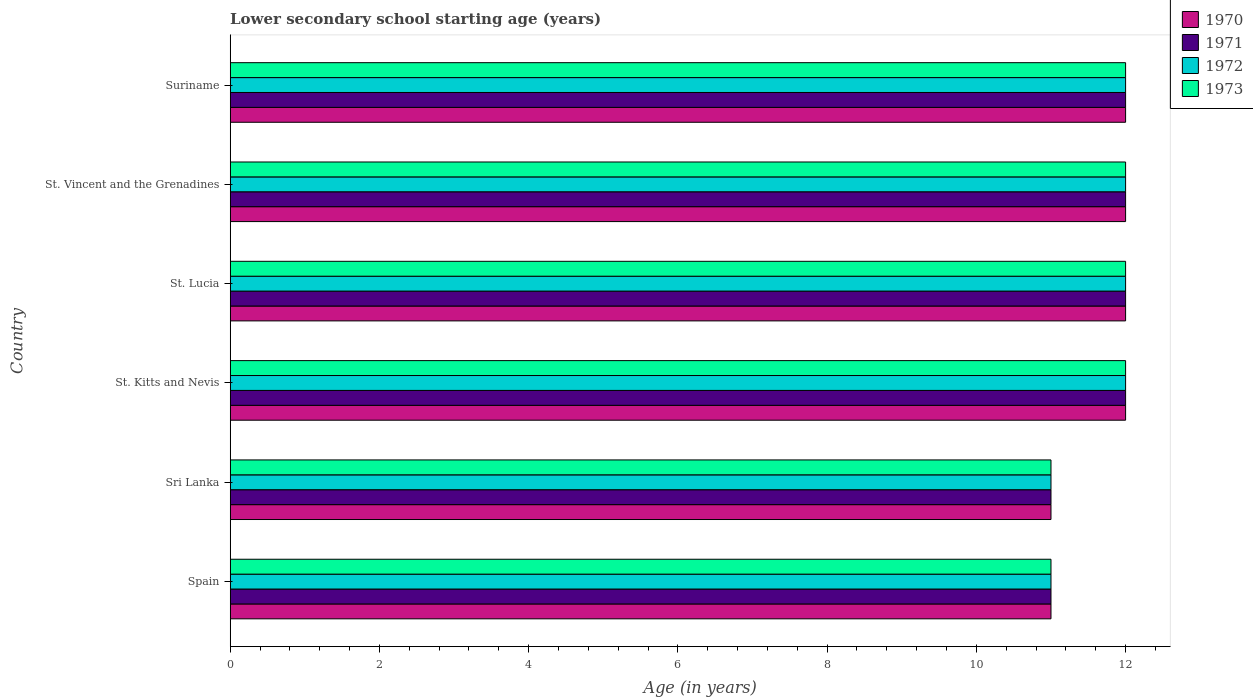How many groups of bars are there?
Offer a terse response. 6. Are the number of bars per tick equal to the number of legend labels?
Your response must be concise. Yes. How many bars are there on the 1st tick from the bottom?
Make the answer very short. 4. What is the label of the 2nd group of bars from the top?
Your response must be concise. St. Vincent and the Grenadines. In how many cases, is the number of bars for a given country not equal to the number of legend labels?
Provide a short and direct response. 0. What is the lower secondary school starting age of children in 1970 in St. Kitts and Nevis?
Offer a terse response. 12. Across all countries, what is the maximum lower secondary school starting age of children in 1973?
Provide a succinct answer. 12. Across all countries, what is the minimum lower secondary school starting age of children in 1973?
Offer a terse response. 11. In which country was the lower secondary school starting age of children in 1970 maximum?
Your response must be concise. St. Kitts and Nevis. What is the average lower secondary school starting age of children in 1972 per country?
Keep it short and to the point. 11.67. In how many countries, is the lower secondary school starting age of children in 1971 greater than 0.8 years?
Keep it short and to the point. 6. What is the ratio of the lower secondary school starting age of children in 1970 in Spain to that in Suriname?
Offer a terse response. 0.92. Is the difference between the lower secondary school starting age of children in 1972 in Sri Lanka and St. Lucia greater than the difference between the lower secondary school starting age of children in 1973 in Sri Lanka and St. Lucia?
Ensure brevity in your answer.  No. In how many countries, is the lower secondary school starting age of children in 1971 greater than the average lower secondary school starting age of children in 1971 taken over all countries?
Offer a very short reply. 4. Is the sum of the lower secondary school starting age of children in 1970 in St. Kitts and Nevis and St. Vincent and the Grenadines greater than the maximum lower secondary school starting age of children in 1972 across all countries?
Your response must be concise. Yes. What does the 2nd bar from the top in St. Vincent and the Grenadines represents?
Offer a very short reply. 1972. What does the 1st bar from the bottom in St. Kitts and Nevis represents?
Make the answer very short. 1970. How many bars are there?
Keep it short and to the point. 24. What is the difference between two consecutive major ticks on the X-axis?
Offer a very short reply. 2. Are the values on the major ticks of X-axis written in scientific E-notation?
Provide a succinct answer. No. Does the graph contain any zero values?
Provide a short and direct response. No. Where does the legend appear in the graph?
Provide a short and direct response. Top right. What is the title of the graph?
Provide a succinct answer. Lower secondary school starting age (years). What is the label or title of the X-axis?
Your response must be concise. Age (in years). What is the Age (in years) of 1971 in Spain?
Your answer should be compact. 11. What is the Age (in years) of 1973 in Spain?
Your response must be concise. 11. What is the Age (in years) of 1970 in Sri Lanka?
Your answer should be very brief. 11. What is the Age (in years) of 1970 in St. Lucia?
Provide a short and direct response. 12. What is the Age (in years) of 1972 in St. Lucia?
Your answer should be compact. 12. What is the Age (in years) in 1971 in St. Vincent and the Grenadines?
Provide a short and direct response. 12. What is the Age (in years) in 1973 in St. Vincent and the Grenadines?
Make the answer very short. 12. What is the Age (in years) in 1972 in Suriname?
Your answer should be compact. 12. Across all countries, what is the maximum Age (in years) of 1971?
Your answer should be compact. 12. Across all countries, what is the maximum Age (in years) in 1972?
Give a very brief answer. 12. Across all countries, what is the minimum Age (in years) in 1971?
Your answer should be compact. 11. What is the total Age (in years) in 1970 in the graph?
Your answer should be compact. 70. What is the total Age (in years) in 1971 in the graph?
Your answer should be very brief. 70. What is the total Age (in years) in 1972 in the graph?
Give a very brief answer. 70. What is the difference between the Age (in years) of 1970 in Spain and that in Sri Lanka?
Ensure brevity in your answer.  0. What is the difference between the Age (in years) of 1972 in Spain and that in Sri Lanka?
Your response must be concise. 0. What is the difference between the Age (in years) of 1970 in Spain and that in St. Kitts and Nevis?
Your answer should be very brief. -1. What is the difference between the Age (in years) of 1973 in Spain and that in St. Kitts and Nevis?
Ensure brevity in your answer.  -1. What is the difference between the Age (in years) in 1970 in Spain and that in St. Lucia?
Ensure brevity in your answer.  -1. What is the difference between the Age (in years) of 1970 in Spain and that in St. Vincent and the Grenadines?
Keep it short and to the point. -1. What is the difference between the Age (in years) in 1971 in Spain and that in St. Vincent and the Grenadines?
Offer a very short reply. -1. What is the difference between the Age (in years) of 1973 in Spain and that in St. Vincent and the Grenadines?
Your answer should be compact. -1. What is the difference between the Age (in years) in 1970 in Spain and that in Suriname?
Keep it short and to the point. -1. What is the difference between the Age (in years) in 1971 in Spain and that in Suriname?
Offer a very short reply. -1. What is the difference between the Age (in years) in 1972 in Spain and that in Suriname?
Your answer should be compact. -1. What is the difference between the Age (in years) of 1972 in Sri Lanka and that in St. Kitts and Nevis?
Provide a short and direct response. -1. What is the difference between the Age (in years) in 1970 in Sri Lanka and that in St. Lucia?
Your answer should be very brief. -1. What is the difference between the Age (in years) of 1971 in Sri Lanka and that in St. Lucia?
Keep it short and to the point. -1. What is the difference between the Age (in years) of 1973 in Sri Lanka and that in St. Lucia?
Offer a terse response. -1. What is the difference between the Age (in years) in 1970 in Sri Lanka and that in St. Vincent and the Grenadines?
Ensure brevity in your answer.  -1. What is the difference between the Age (in years) in 1971 in Sri Lanka and that in St. Vincent and the Grenadines?
Your answer should be very brief. -1. What is the difference between the Age (in years) of 1972 in Sri Lanka and that in St. Vincent and the Grenadines?
Make the answer very short. -1. What is the difference between the Age (in years) of 1973 in Sri Lanka and that in St. Vincent and the Grenadines?
Your answer should be very brief. -1. What is the difference between the Age (in years) in 1971 in Sri Lanka and that in Suriname?
Offer a terse response. -1. What is the difference between the Age (in years) in 1973 in Sri Lanka and that in Suriname?
Your response must be concise. -1. What is the difference between the Age (in years) of 1971 in St. Kitts and Nevis and that in St. Lucia?
Give a very brief answer. 0. What is the difference between the Age (in years) of 1972 in St. Kitts and Nevis and that in St. Lucia?
Offer a very short reply. 0. What is the difference between the Age (in years) of 1970 in St. Kitts and Nevis and that in St. Vincent and the Grenadines?
Provide a short and direct response. 0. What is the difference between the Age (in years) in 1971 in St. Kitts and Nevis and that in Suriname?
Your response must be concise. 0. What is the difference between the Age (in years) of 1972 in St. Lucia and that in St. Vincent and the Grenadines?
Give a very brief answer. 0. What is the difference between the Age (in years) of 1973 in St. Lucia and that in St. Vincent and the Grenadines?
Keep it short and to the point. 0. What is the difference between the Age (in years) of 1971 in St. Lucia and that in Suriname?
Make the answer very short. 0. What is the difference between the Age (in years) of 1971 in St. Vincent and the Grenadines and that in Suriname?
Offer a terse response. 0. What is the difference between the Age (in years) in 1973 in St. Vincent and the Grenadines and that in Suriname?
Give a very brief answer. 0. What is the difference between the Age (in years) in 1970 in Spain and the Age (in years) in 1971 in Sri Lanka?
Offer a very short reply. 0. What is the difference between the Age (in years) in 1970 in Spain and the Age (in years) in 1972 in Sri Lanka?
Give a very brief answer. 0. What is the difference between the Age (in years) of 1970 in Spain and the Age (in years) of 1973 in Sri Lanka?
Your answer should be compact. 0. What is the difference between the Age (in years) of 1971 in Spain and the Age (in years) of 1973 in Sri Lanka?
Your answer should be very brief. 0. What is the difference between the Age (in years) of 1972 in Spain and the Age (in years) of 1973 in Sri Lanka?
Give a very brief answer. 0. What is the difference between the Age (in years) in 1970 in Spain and the Age (in years) in 1972 in St. Kitts and Nevis?
Keep it short and to the point. -1. What is the difference between the Age (in years) of 1971 in Spain and the Age (in years) of 1973 in St. Kitts and Nevis?
Ensure brevity in your answer.  -1. What is the difference between the Age (in years) of 1972 in Spain and the Age (in years) of 1973 in St. Kitts and Nevis?
Ensure brevity in your answer.  -1. What is the difference between the Age (in years) of 1970 in Spain and the Age (in years) of 1973 in St. Lucia?
Give a very brief answer. -1. What is the difference between the Age (in years) in 1971 in Spain and the Age (in years) in 1973 in St. Lucia?
Make the answer very short. -1. What is the difference between the Age (in years) of 1972 in Spain and the Age (in years) of 1973 in St. Lucia?
Your response must be concise. -1. What is the difference between the Age (in years) of 1970 in Spain and the Age (in years) of 1971 in St. Vincent and the Grenadines?
Your response must be concise. -1. What is the difference between the Age (in years) in 1970 in Spain and the Age (in years) in 1973 in St. Vincent and the Grenadines?
Make the answer very short. -1. What is the difference between the Age (in years) in 1971 in Spain and the Age (in years) in 1972 in St. Vincent and the Grenadines?
Provide a succinct answer. -1. What is the difference between the Age (in years) of 1970 in Spain and the Age (in years) of 1971 in Suriname?
Give a very brief answer. -1. What is the difference between the Age (in years) of 1970 in Spain and the Age (in years) of 1973 in Suriname?
Your answer should be very brief. -1. What is the difference between the Age (in years) of 1971 in Spain and the Age (in years) of 1972 in Suriname?
Your answer should be compact. -1. What is the difference between the Age (in years) in 1971 in Sri Lanka and the Age (in years) in 1972 in St. Kitts and Nevis?
Your answer should be very brief. -1. What is the difference between the Age (in years) of 1971 in Sri Lanka and the Age (in years) of 1973 in St. Kitts and Nevis?
Provide a short and direct response. -1. What is the difference between the Age (in years) in 1970 in Sri Lanka and the Age (in years) in 1973 in St. Lucia?
Make the answer very short. -1. What is the difference between the Age (in years) in 1971 in Sri Lanka and the Age (in years) in 1972 in St. Lucia?
Your answer should be compact. -1. What is the difference between the Age (in years) in 1971 in Sri Lanka and the Age (in years) in 1973 in St. Lucia?
Ensure brevity in your answer.  -1. What is the difference between the Age (in years) of 1970 in Sri Lanka and the Age (in years) of 1971 in St. Vincent and the Grenadines?
Your answer should be compact. -1. What is the difference between the Age (in years) of 1970 in Sri Lanka and the Age (in years) of 1973 in St. Vincent and the Grenadines?
Keep it short and to the point. -1. What is the difference between the Age (in years) in 1971 in Sri Lanka and the Age (in years) in 1973 in St. Vincent and the Grenadines?
Keep it short and to the point. -1. What is the difference between the Age (in years) of 1970 in Sri Lanka and the Age (in years) of 1971 in Suriname?
Provide a succinct answer. -1. What is the difference between the Age (in years) in 1970 in Sri Lanka and the Age (in years) in 1973 in Suriname?
Offer a terse response. -1. What is the difference between the Age (in years) of 1971 in Sri Lanka and the Age (in years) of 1973 in Suriname?
Ensure brevity in your answer.  -1. What is the difference between the Age (in years) in 1972 in St. Kitts and Nevis and the Age (in years) in 1973 in St. Lucia?
Offer a very short reply. 0. What is the difference between the Age (in years) of 1970 in St. Kitts and Nevis and the Age (in years) of 1971 in St. Vincent and the Grenadines?
Offer a terse response. 0. What is the difference between the Age (in years) of 1972 in St. Kitts and Nevis and the Age (in years) of 1973 in St. Vincent and the Grenadines?
Your answer should be compact. 0. What is the difference between the Age (in years) in 1970 in St. Kitts and Nevis and the Age (in years) in 1971 in Suriname?
Offer a terse response. 0. What is the difference between the Age (in years) in 1970 in St. Kitts and Nevis and the Age (in years) in 1973 in Suriname?
Your response must be concise. 0. What is the difference between the Age (in years) of 1971 in St. Kitts and Nevis and the Age (in years) of 1972 in Suriname?
Give a very brief answer. 0. What is the difference between the Age (in years) in 1971 in St. Kitts and Nevis and the Age (in years) in 1973 in Suriname?
Keep it short and to the point. 0. What is the difference between the Age (in years) of 1970 in St. Lucia and the Age (in years) of 1971 in St. Vincent and the Grenadines?
Offer a very short reply. 0. What is the difference between the Age (in years) of 1970 in St. Lucia and the Age (in years) of 1972 in St. Vincent and the Grenadines?
Offer a terse response. 0. What is the difference between the Age (in years) in 1970 in St. Lucia and the Age (in years) in 1973 in St. Vincent and the Grenadines?
Make the answer very short. 0. What is the difference between the Age (in years) of 1971 in St. Lucia and the Age (in years) of 1972 in St. Vincent and the Grenadines?
Provide a short and direct response. 0. What is the difference between the Age (in years) of 1970 in St. Lucia and the Age (in years) of 1972 in Suriname?
Give a very brief answer. 0. What is the difference between the Age (in years) in 1970 in St. Lucia and the Age (in years) in 1973 in Suriname?
Your answer should be compact. 0. What is the difference between the Age (in years) in 1971 in St. Lucia and the Age (in years) in 1972 in Suriname?
Your answer should be very brief. 0. What is the difference between the Age (in years) of 1971 in St. Lucia and the Age (in years) of 1973 in Suriname?
Your response must be concise. 0. What is the difference between the Age (in years) in 1972 in St. Lucia and the Age (in years) in 1973 in Suriname?
Your response must be concise. 0. What is the difference between the Age (in years) of 1970 in St. Vincent and the Grenadines and the Age (in years) of 1973 in Suriname?
Your response must be concise. 0. What is the average Age (in years) in 1970 per country?
Your response must be concise. 11.67. What is the average Age (in years) in 1971 per country?
Your answer should be compact. 11.67. What is the average Age (in years) of 1972 per country?
Your response must be concise. 11.67. What is the average Age (in years) of 1973 per country?
Offer a terse response. 11.67. What is the difference between the Age (in years) of 1970 and Age (in years) of 1971 in Spain?
Your answer should be compact. 0. What is the difference between the Age (in years) in 1970 and Age (in years) in 1973 in Spain?
Your answer should be compact. 0. What is the difference between the Age (in years) of 1971 and Age (in years) of 1972 in Spain?
Your answer should be compact. 0. What is the difference between the Age (in years) in 1971 and Age (in years) in 1973 in Spain?
Your answer should be compact. 0. What is the difference between the Age (in years) in 1970 and Age (in years) in 1972 in Sri Lanka?
Keep it short and to the point. 0. What is the difference between the Age (in years) of 1970 and Age (in years) of 1973 in Sri Lanka?
Provide a short and direct response. 0. What is the difference between the Age (in years) in 1971 and Age (in years) in 1973 in Sri Lanka?
Give a very brief answer. 0. What is the difference between the Age (in years) in 1970 and Age (in years) in 1971 in St. Kitts and Nevis?
Provide a short and direct response. 0. What is the difference between the Age (in years) of 1970 and Age (in years) of 1972 in St. Kitts and Nevis?
Provide a short and direct response. 0. What is the difference between the Age (in years) of 1972 and Age (in years) of 1973 in St. Kitts and Nevis?
Make the answer very short. 0. What is the difference between the Age (in years) in 1970 and Age (in years) in 1973 in St. Lucia?
Your answer should be compact. 0. What is the difference between the Age (in years) in 1972 and Age (in years) in 1973 in St. Lucia?
Make the answer very short. 0. What is the difference between the Age (in years) of 1970 and Age (in years) of 1971 in St. Vincent and the Grenadines?
Give a very brief answer. 0. What is the difference between the Age (in years) of 1971 and Age (in years) of 1973 in St. Vincent and the Grenadines?
Give a very brief answer. 0. What is the difference between the Age (in years) of 1972 and Age (in years) of 1973 in St. Vincent and the Grenadines?
Provide a short and direct response. 0. What is the difference between the Age (in years) of 1970 and Age (in years) of 1971 in Suriname?
Your answer should be compact. 0. What is the difference between the Age (in years) of 1970 and Age (in years) of 1972 in Suriname?
Keep it short and to the point. 0. What is the difference between the Age (in years) in 1970 and Age (in years) in 1973 in Suriname?
Offer a terse response. 0. What is the difference between the Age (in years) of 1971 and Age (in years) of 1972 in Suriname?
Your answer should be very brief. 0. What is the ratio of the Age (in years) of 1972 in Spain to that in Sri Lanka?
Ensure brevity in your answer.  1. What is the ratio of the Age (in years) of 1973 in Spain to that in St. Kitts and Nevis?
Your response must be concise. 0.92. What is the ratio of the Age (in years) of 1971 in Spain to that in St. Lucia?
Provide a short and direct response. 0.92. What is the ratio of the Age (in years) in 1973 in Spain to that in St. Lucia?
Ensure brevity in your answer.  0.92. What is the ratio of the Age (in years) in 1971 in Spain to that in St. Vincent and the Grenadines?
Your answer should be very brief. 0.92. What is the ratio of the Age (in years) of 1972 in Spain to that in St. Vincent and the Grenadines?
Keep it short and to the point. 0.92. What is the ratio of the Age (in years) of 1973 in Spain to that in St. Vincent and the Grenadines?
Offer a very short reply. 0.92. What is the ratio of the Age (in years) of 1971 in Spain to that in Suriname?
Keep it short and to the point. 0.92. What is the ratio of the Age (in years) of 1973 in Spain to that in Suriname?
Give a very brief answer. 0.92. What is the ratio of the Age (in years) of 1972 in Sri Lanka to that in St. Kitts and Nevis?
Your response must be concise. 0.92. What is the ratio of the Age (in years) of 1973 in Sri Lanka to that in St. Kitts and Nevis?
Provide a succinct answer. 0.92. What is the ratio of the Age (in years) of 1973 in Sri Lanka to that in St. Lucia?
Provide a succinct answer. 0.92. What is the ratio of the Age (in years) of 1971 in Sri Lanka to that in St. Vincent and the Grenadines?
Your answer should be compact. 0.92. What is the ratio of the Age (in years) of 1970 in Sri Lanka to that in Suriname?
Offer a terse response. 0.92. What is the ratio of the Age (in years) of 1971 in Sri Lanka to that in Suriname?
Ensure brevity in your answer.  0.92. What is the ratio of the Age (in years) in 1972 in Sri Lanka to that in Suriname?
Keep it short and to the point. 0.92. What is the ratio of the Age (in years) of 1973 in Sri Lanka to that in Suriname?
Make the answer very short. 0.92. What is the ratio of the Age (in years) of 1972 in St. Kitts and Nevis to that in St. Lucia?
Your answer should be compact. 1. What is the ratio of the Age (in years) of 1973 in St. Kitts and Nevis to that in St. Lucia?
Give a very brief answer. 1. What is the ratio of the Age (in years) in 1970 in St. Kitts and Nevis to that in St. Vincent and the Grenadines?
Provide a succinct answer. 1. What is the ratio of the Age (in years) of 1973 in St. Kitts and Nevis to that in St. Vincent and the Grenadines?
Keep it short and to the point. 1. What is the ratio of the Age (in years) of 1971 in St. Kitts and Nevis to that in Suriname?
Ensure brevity in your answer.  1. What is the ratio of the Age (in years) of 1973 in St. Kitts and Nevis to that in Suriname?
Provide a succinct answer. 1. What is the ratio of the Age (in years) in 1971 in St. Lucia to that in St. Vincent and the Grenadines?
Provide a short and direct response. 1. What is the ratio of the Age (in years) of 1972 in St. Lucia to that in St. Vincent and the Grenadines?
Your response must be concise. 1. What is the ratio of the Age (in years) of 1970 in St. Lucia to that in Suriname?
Provide a succinct answer. 1. What is the ratio of the Age (in years) of 1971 in St. Lucia to that in Suriname?
Provide a short and direct response. 1. What is the ratio of the Age (in years) of 1972 in St. Lucia to that in Suriname?
Your answer should be very brief. 1. What is the ratio of the Age (in years) of 1970 in St. Vincent and the Grenadines to that in Suriname?
Provide a short and direct response. 1. What is the ratio of the Age (in years) of 1973 in St. Vincent and the Grenadines to that in Suriname?
Offer a terse response. 1. What is the difference between the highest and the second highest Age (in years) of 1972?
Provide a short and direct response. 0. What is the difference between the highest and the second highest Age (in years) of 1973?
Keep it short and to the point. 0. What is the difference between the highest and the lowest Age (in years) of 1970?
Offer a terse response. 1. 